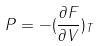<formula> <loc_0><loc_0><loc_500><loc_500>P = - ( \frac { \partial F } { \partial V } ) _ { T }</formula> 